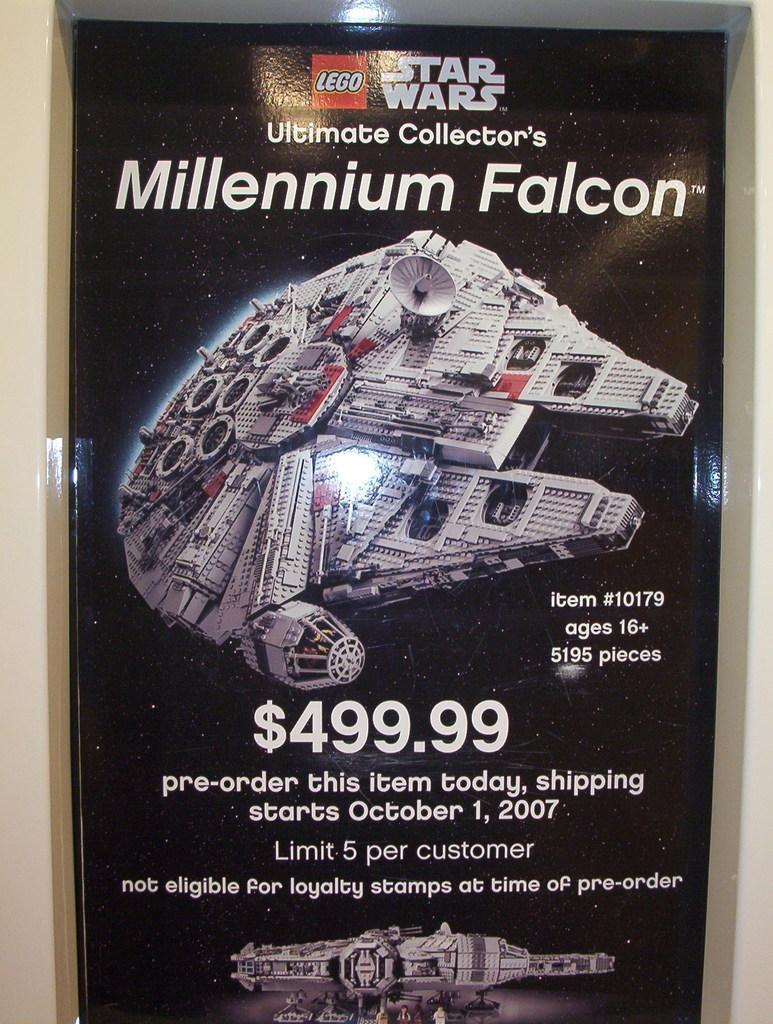<image>
Render a clear and concise summary of the photo. A print advertisement for Lego Star Wars Millennium Falcon. 